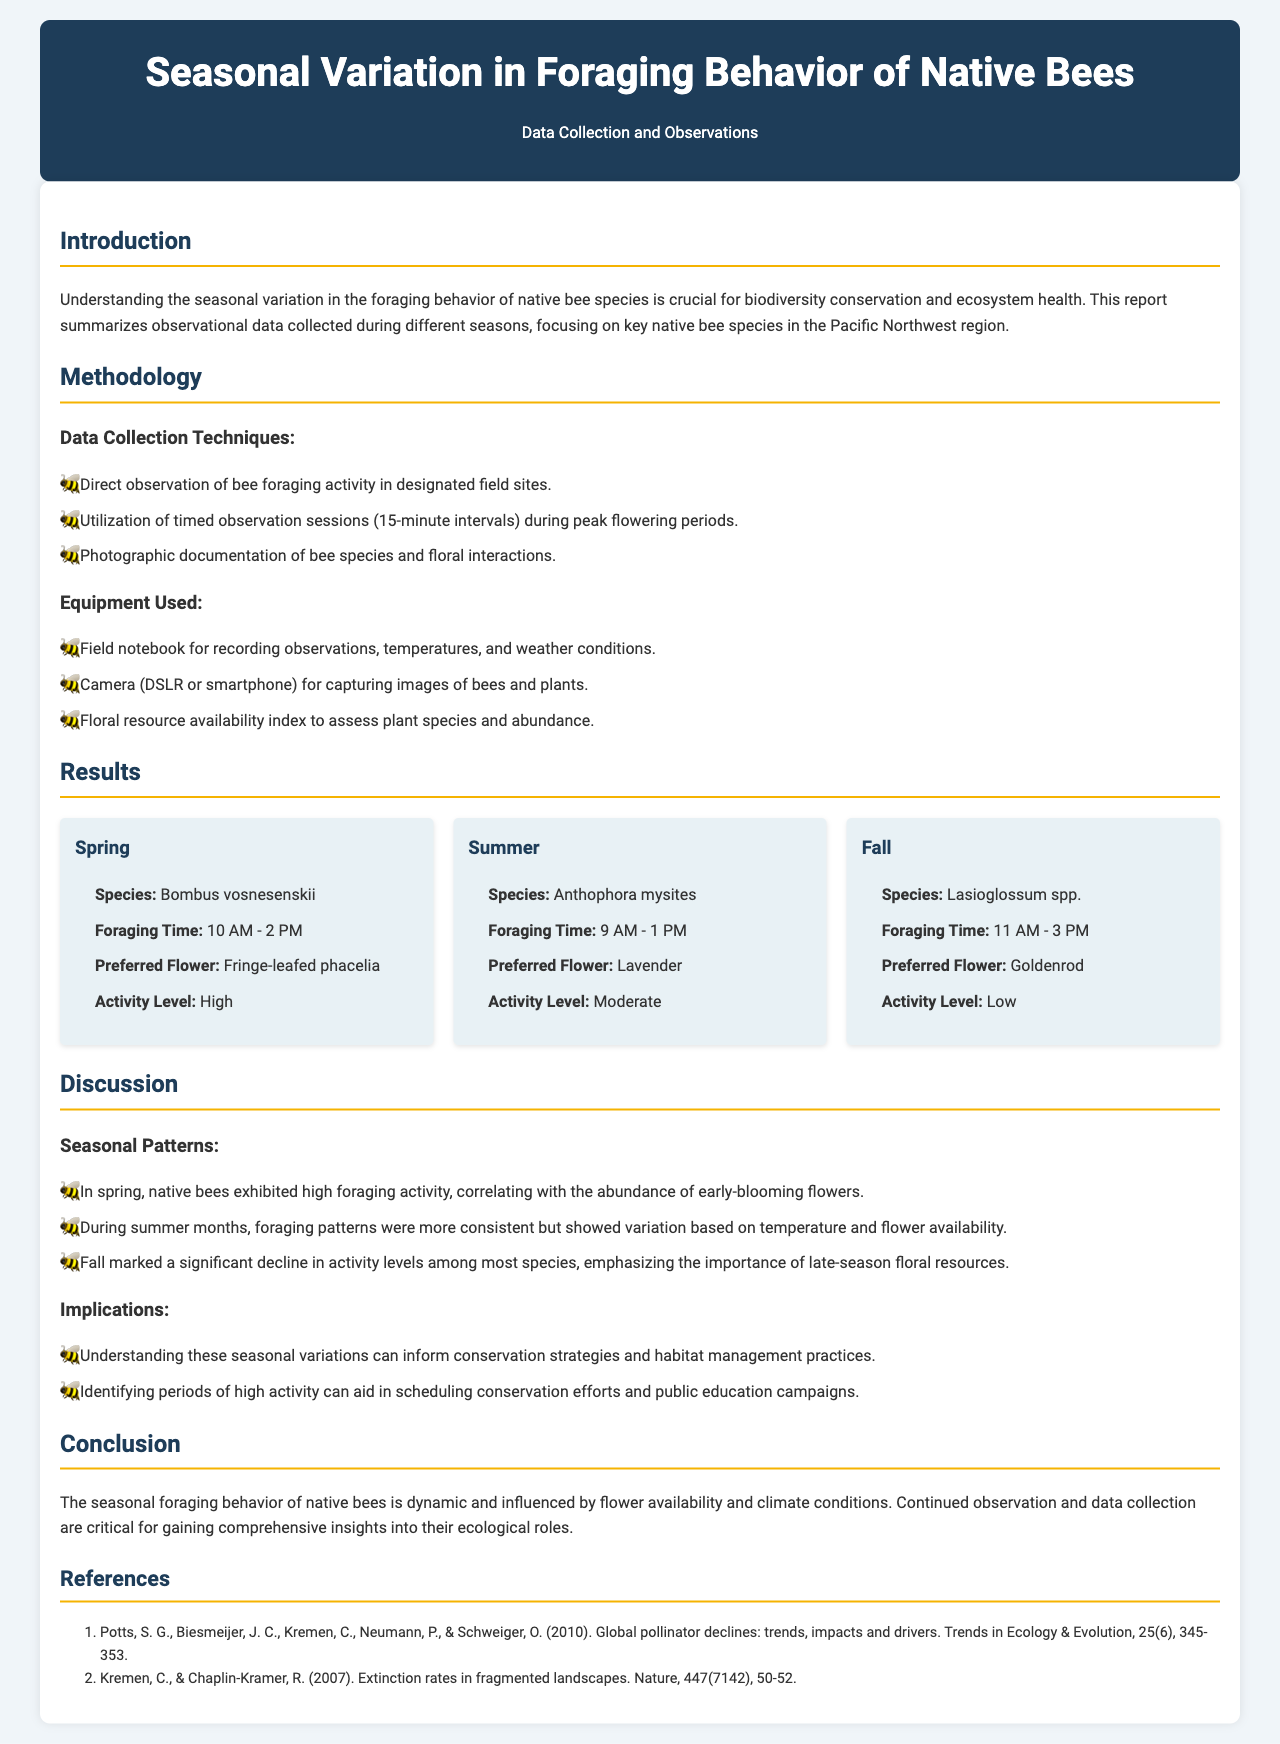what is the title of the report? The title of the report is stated in the header section of the document.
Answer: Seasonal Variation in Foraging Behavior of Native Bees what is the primary focus of this report? The primary focus is outlined in the introduction section.
Answer: Seasonal variation in foraging behavior of native bee species which bee species was observed in spring? The specific bee species observed in spring is listed under the results section.
Answer: Bombus vosnesenskii what time did the native bees forage in summer? The foraging time for summer is specified in the results section under the summer card.
Answer: 9 AM - 1 PM what was the activity level of bees in fall? The activity level for fall is indicated in the results section.
Answer: Low which flower was preferred by bees during spring? The preferred flower during spring is detailed in the results section.
Answer: Fringe-leafed phacelia what is the major implication of understanding seasonal variations in bee behavior? The implications are discussed in the discussion section.
Answer: Inform conservation strategies how many methods were listed for data collection? The number of methods can be counted in the methodology section.
Answer: Three what type of document is this? The category of this document is stated in the header and introduction.
Answer: Research report 